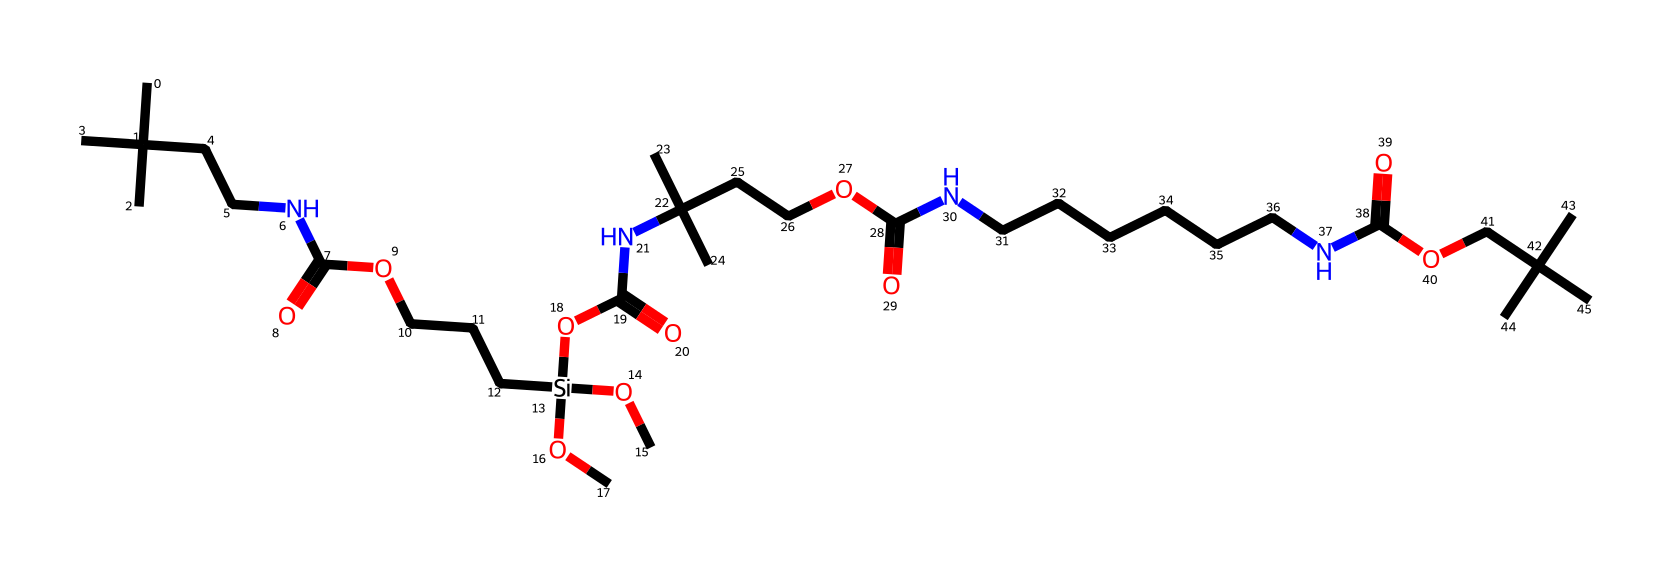What is the main functional group in this silane-modified polyurethane? The chemical contains multiple amide groups as identified by the presence of nitrogen and carbonyl (C=O) adjacent to nitrogen atoms. This indicates that the main functional group is amide.
Answer: amide How many silicon atoms are present in this chemical? By examining the structure, we can see there is one silicon atom indicated in the SMILES representation, which appears as [Si](OC)(OC)OC.
Answer: one What does the presence of silane contribute to the properties of this polyurethane? Silane typically enhances adhesion and improves water resistance in polymers, which is beneficial for durable studio equipment casing materials.
Answer: adhesion What is the total number of carbon atoms in this structure? By counting the carbon atoms represented in the SMILES string, we identify that there are 32 carbon atoms present in total.
Answer: thirty-two Which type of bond is predominantly present due to the carbon and oxygen relationships in this structure? Within the structure, there are several carbonyl (C=O) bonds from the presence of the carboxylic and amide functionalities. Thus, the predominant bond type including these groups is a carbonyl bond.
Answer: carbonyl What is the relationship between the silane groups and the polyurethane structure? The silane groups modify the polyurethane backbone, improving durability and performance of the material by creating a more robust network, which is beneficial for enclosing electronic equipment.
Answer: modification 